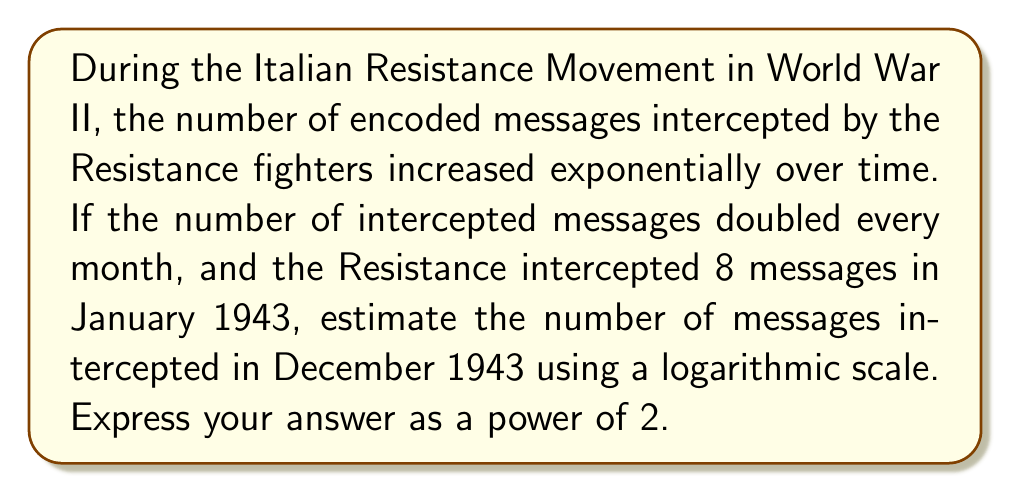What is the answer to this math problem? To solve this problem, we'll use the properties of exponential growth and logarithms:

1) First, let's establish the exponential growth pattern:
   - January: $2^3 = 8$ messages (given)
   - February: $2^4 = 16$ messages
   - March: $2^5 = 32$ messages
   ...and so on

2) We need to determine how many months passed from January to December:
   12 months

3) Since the number of messages doubles each month, we add 1 to the exponent for each month:
   December's exponent = January's exponent + number of months
   $$ \text{December's exponent} = 3 + 12 = 15 $$

4) Therefore, the number of messages in December can be expressed as:
   $$ 2^{15} \text{ messages} $$

5) To verify this using logarithms:
   $$ \log_2(\text{December messages}) = 15 $$

   This confirms that our answer is correct in terms of the power of 2.
Answer: $2^{15}$ messages 